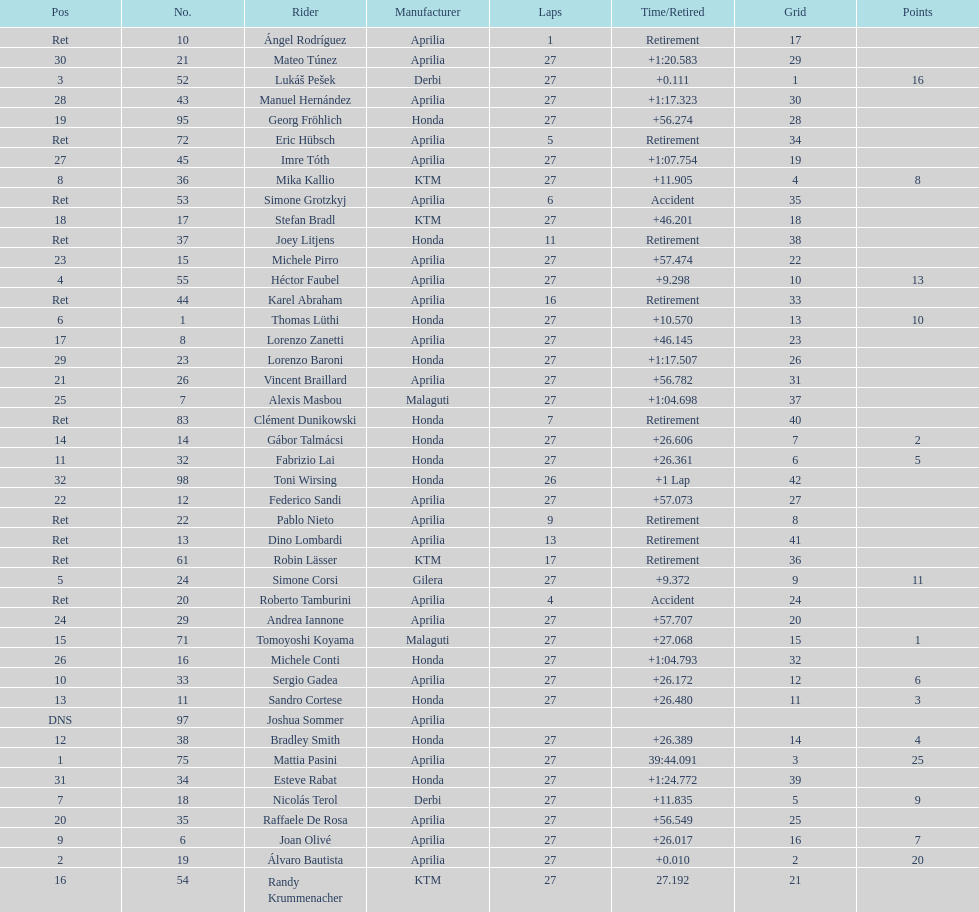How many german racers finished the race? 4. 